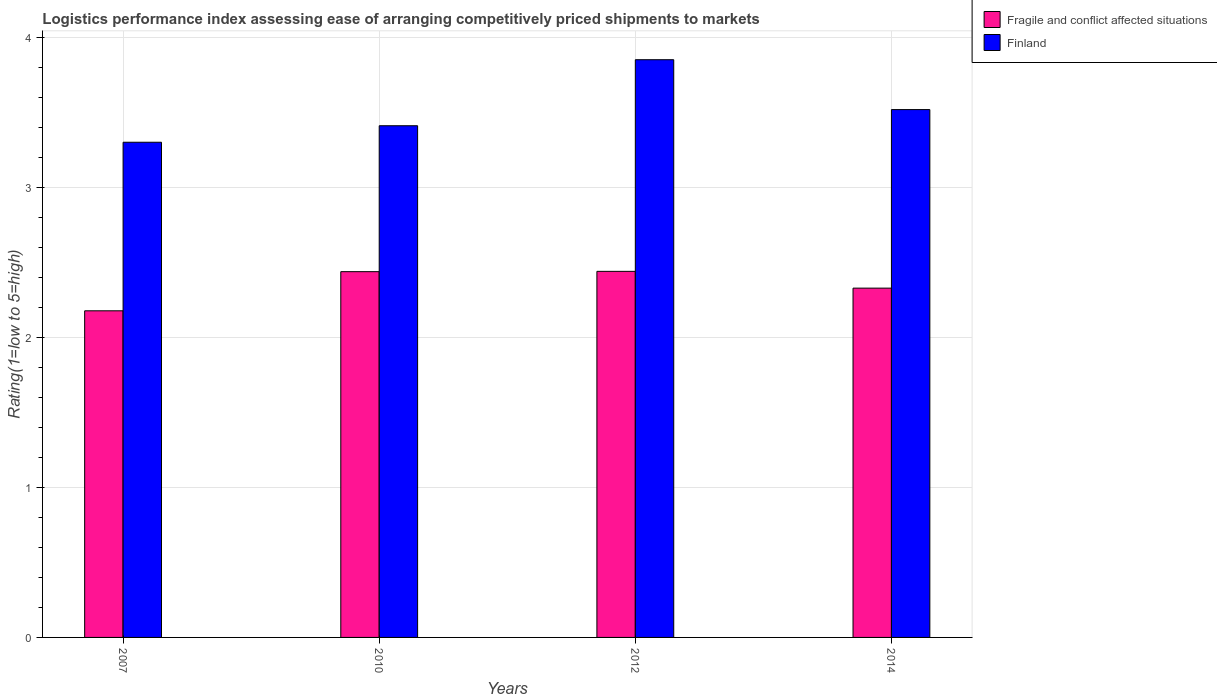How many different coloured bars are there?
Your response must be concise. 2. Are the number of bars per tick equal to the number of legend labels?
Offer a very short reply. Yes. How many bars are there on the 3rd tick from the right?
Give a very brief answer. 2. What is the label of the 4th group of bars from the left?
Your answer should be compact. 2014. What is the Logistic performance index in Fragile and conflict affected situations in 2012?
Give a very brief answer. 2.44. Across all years, what is the maximum Logistic performance index in Finland?
Provide a succinct answer. 3.85. Across all years, what is the minimum Logistic performance index in Fragile and conflict affected situations?
Offer a terse response. 2.18. In which year was the Logistic performance index in Fragile and conflict affected situations minimum?
Your answer should be very brief. 2007. What is the total Logistic performance index in Fragile and conflict affected situations in the graph?
Make the answer very short. 9.38. What is the difference between the Logistic performance index in Finland in 2010 and that in 2014?
Provide a short and direct response. -0.11. What is the difference between the Logistic performance index in Finland in 2010 and the Logistic performance index in Fragile and conflict affected situations in 2012?
Offer a very short reply. 0.97. What is the average Logistic performance index in Fragile and conflict affected situations per year?
Offer a very short reply. 2.35. In the year 2007, what is the difference between the Logistic performance index in Fragile and conflict affected situations and Logistic performance index in Finland?
Your response must be concise. -1.12. What is the ratio of the Logistic performance index in Finland in 2010 to that in 2012?
Your response must be concise. 0.89. Is the Logistic performance index in Finland in 2007 less than that in 2014?
Your answer should be compact. Yes. Is the difference between the Logistic performance index in Fragile and conflict affected situations in 2012 and 2014 greater than the difference between the Logistic performance index in Finland in 2012 and 2014?
Keep it short and to the point. No. What is the difference between the highest and the second highest Logistic performance index in Finland?
Ensure brevity in your answer.  0.33. What is the difference between the highest and the lowest Logistic performance index in Fragile and conflict affected situations?
Your response must be concise. 0.26. Are all the bars in the graph horizontal?
Make the answer very short. No. How many years are there in the graph?
Keep it short and to the point. 4. Are the values on the major ticks of Y-axis written in scientific E-notation?
Provide a short and direct response. No. Does the graph contain any zero values?
Ensure brevity in your answer.  No. What is the title of the graph?
Provide a succinct answer. Logistics performance index assessing ease of arranging competitively priced shipments to markets. What is the label or title of the Y-axis?
Your answer should be compact. Rating(1=low to 5=high). What is the Rating(1=low to 5=high) of Fragile and conflict affected situations in 2007?
Provide a short and direct response. 2.18. What is the Rating(1=low to 5=high) in Fragile and conflict affected situations in 2010?
Your answer should be compact. 2.44. What is the Rating(1=low to 5=high) in Finland in 2010?
Keep it short and to the point. 3.41. What is the Rating(1=low to 5=high) in Fragile and conflict affected situations in 2012?
Offer a terse response. 2.44. What is the Rating(1=low to 5=high) of Finland in 2012?
Provide a short and direct response. 3.85. What is the Rating(1=low to 5=high) in Fragile and conflict affected situations in 2014?
Offer a terse response. 2.33. What is the Rating(1=low to 5=high) in Finland in 2014?
Your answer should be very brief. 3.52. Across all years, what is the maximum Rating(1=low to 5=high) in Fragile and conflict affected situations?
Provide a succinct answer. 2.44. Across all years, what is the maximum Rating(1=low to 5=high) of Finland?
Ensure brevity in your answer.  3.85. Across all years, what is the minimum Rating(1=low to 5=high) of Fragile and conflict affected situations?
Offer a terse response. 2.18. Across all years, what is the minimum Rating(1=low to 5=high) of Finland?
Provide a short and direct response. 3.3. What is the total Rating(1=low to 5=high) in Fragile and conflict affected situations in the graph?
Offer a very short reply. 9.38. What is the total Rating(1=low to 5=high) in Finland in the graph?
Make the answer very short. 14.08. What is the difference between the Rating(1=low to 5=high) in Fragile and conflict affected situations in 2007 and that in 2010?
Ensure brevity in your answer.  -0.26. What is the difference between the Rating(1=low to 5=high) of Finland in 2007 and that in 2010?
Offer a very short reply. -0.11. What is the difference between the Rating(1=low to 5=high) in Fragile and conflict affected situations in 2007 and that in 2012?
Your response must be concise. -0.26. What is the difference between the Rating(1=low to 5=high) of Finland in 2007 and that in 2012?
Give a very brief answer. -0.55. What is the difference between the Rating(1=low to 5=high) in Fragile and conflict affected situations in 2007 and that in 2014?
Your answer should be very brief. -0.15. What is the difference between the Rating(1=low to 5=high) of Finland in 2007 and that in 2014?
Provide a short and direct response. -0.22. What is the difference between the Rating(1=low to 5=high) of Fragile and conflict affected situations in 2010 and that in 2012?
Offer a terse response. -0. What is the difference between the Rating(1=low to 5=high) of Finland in 2010 and that in 2012?
Your response must be concise. -0.44. What is the difference between the Rating(1=low to 5=high) of Fragile and conflict affected situations in 2010 and that in 2014?
Your answer should be compact. 0.11. What is the difference between the Rating(1=low to 5=high) of Finland in 2010 and that in 2014?
Give a very brief answer. -0.11. What is the difference between the Rating(1=low to 5=high) of Fragile and conflict affected situations in 2012 and that in 2014?
Ensure brevity in your answer.  0.11. What is the difference between the Rating(1=low to 5=high) of Finland in 2012 and that in 2014?
Offer a terse response. 0.33. What is the difference between the Rating(1=low to 5=high) of Fragile and conflict affected situations in 2007 and the Rating(1=low to 5=high) of Finland in 2010?
Make the answer very short. -1.23. What is the difference between the Rating(1=low to 5=high) in Fragile and conflict affected situations in 2007 and the Rating(1=low to 5=high) in Finland in 2012?
Your answer should be compact. -1.67. What is the difference between the Rating(1=low to 5=high) in Fragile and conflict affected situations in 2007 and the Rating(1=low to 5=high) in Finland in 2014?
Make the answer very short. -1.34. What is the difference between the Rating(1=low to 5=high) of Fragile and conflict affected situations in 2010 and the Rating(1=low to 5=high) of Finland in 2012?
Make the answer very short. -1.41. What is the difference between the Rating(1=low to 5=high) in Fragile and conflict affected situations in 2010 and the Rating(1=low to 5=high) in Finland in 2014?
Provide a short and direct response. -1.08. What is the difference between the Rating(1=low to 5=high) of Fragile and conflict affected situations in 2012 and the Rating(1=low to 5=high) of Finland in 2014?
Keep it short and to the point. -1.08. What is the average Rating(1=low to 5=high) of Fragile and conflict affected situations per year?
Your answer should be very brief. 2.35. What is the average Rating(1=low to 5=high) of Finland per year?
Offer a terse response. 3.52. In the year 2007, what is the difference between the Rating(1=low to 5=high) of Fragile and conflict affected situations and Rating(1=low to 5=high) of Finland?
Keep it short and to the point. -1.12. In the year 2010, what is the difference between the Rating(1=low to 5=high) in Fragile and conflict affected situations and Rating(1=low to 5=high) in Finland?
Keep it short and to the point. -0.97. In the year 2012, what is the difference between the Rating(1=low to 5=high) of Fragile and conflict affected situations and Rating(1=low to 5=high) of Finland?
Give a very brief answer. -1.41. In the year 2014, what is the difference between the Rating(1=low to 5=high) of Fragile and conflict affected situations and Rating(1=low to 5=high) of Finland?
Your response must be concise. -1.19. What is the ratio of the Rating(1=low to 5=high) in Fragile and conflict affected situations in 2007 to that in 2010?
Provide a succinct answer. 0.89. What is the ratio of the Rating(1=low to 5=high) of Finland in 2007 to that in 2010?
Ensure brevity in your answer.  0.97. What is the ratio of the Rating(1=low to 5=high) in Fragile and conflict affected situations in 2007 to that in 2012?
Keep it short and to the point. 0.89. What is the ratio of the Rating(1=low to 5=high) in Finland in 2007 to that in 2012?
Keep it short and to the point. 0.86. What is the ratio of the Rating(1=low to 5=high) of Fragile and conflict affected situations in 2007 to that in 2014?
Offer a very short reply. 0.94. What is the ratio of the Rating(1=low to 5=high) of Finland in 2007 to that in 2014?
Offer a terse response. 0.94. What is the ratio of the Rating(1=low to 5=high) in Finland in 2010 to that in 2012?
Your answer should be very brief. 0.89. What is the ratio of the Rating(1=low to 5=high) of Fragile and conflict affected situations in 2010 to that in 2014?
Provide a succinct answer. 1.05. What is the ratio of the Rating(1=low to 5=high) in Finland in 2010 to that in 2014?
Keep it short and to the point. 0.97. What is the ratio of the Rating(1=low to 5=high) in Fragile and conflict affected situations in 2012 to that in 2014?
Ensure brevity in your answer.  1.05. What is the ratio of the Rating(1=low to 5=high) in Finland in 2012 to that in 2014?
Provide a short and direct response. 1.09. What is the difference between the highest and the second highest Rating(1=low to 5=high) of Fragile and conflict affected situations?
Ensure brevity in your answer.  0. What is the difference between the highest and the second highest Rating(1=low to 5=high) in Finland?
Your answer should be very brief. 0.33. What is the difference between the highest and the lowest Rating(1=low to 5=high) of Fragile and conflict affected situations?
Your response must be concise. 0.26. What is the difference between the highest and the lowest Rating(1=low to 5=high) of Finland?
Offer a terse response. 0.55. 